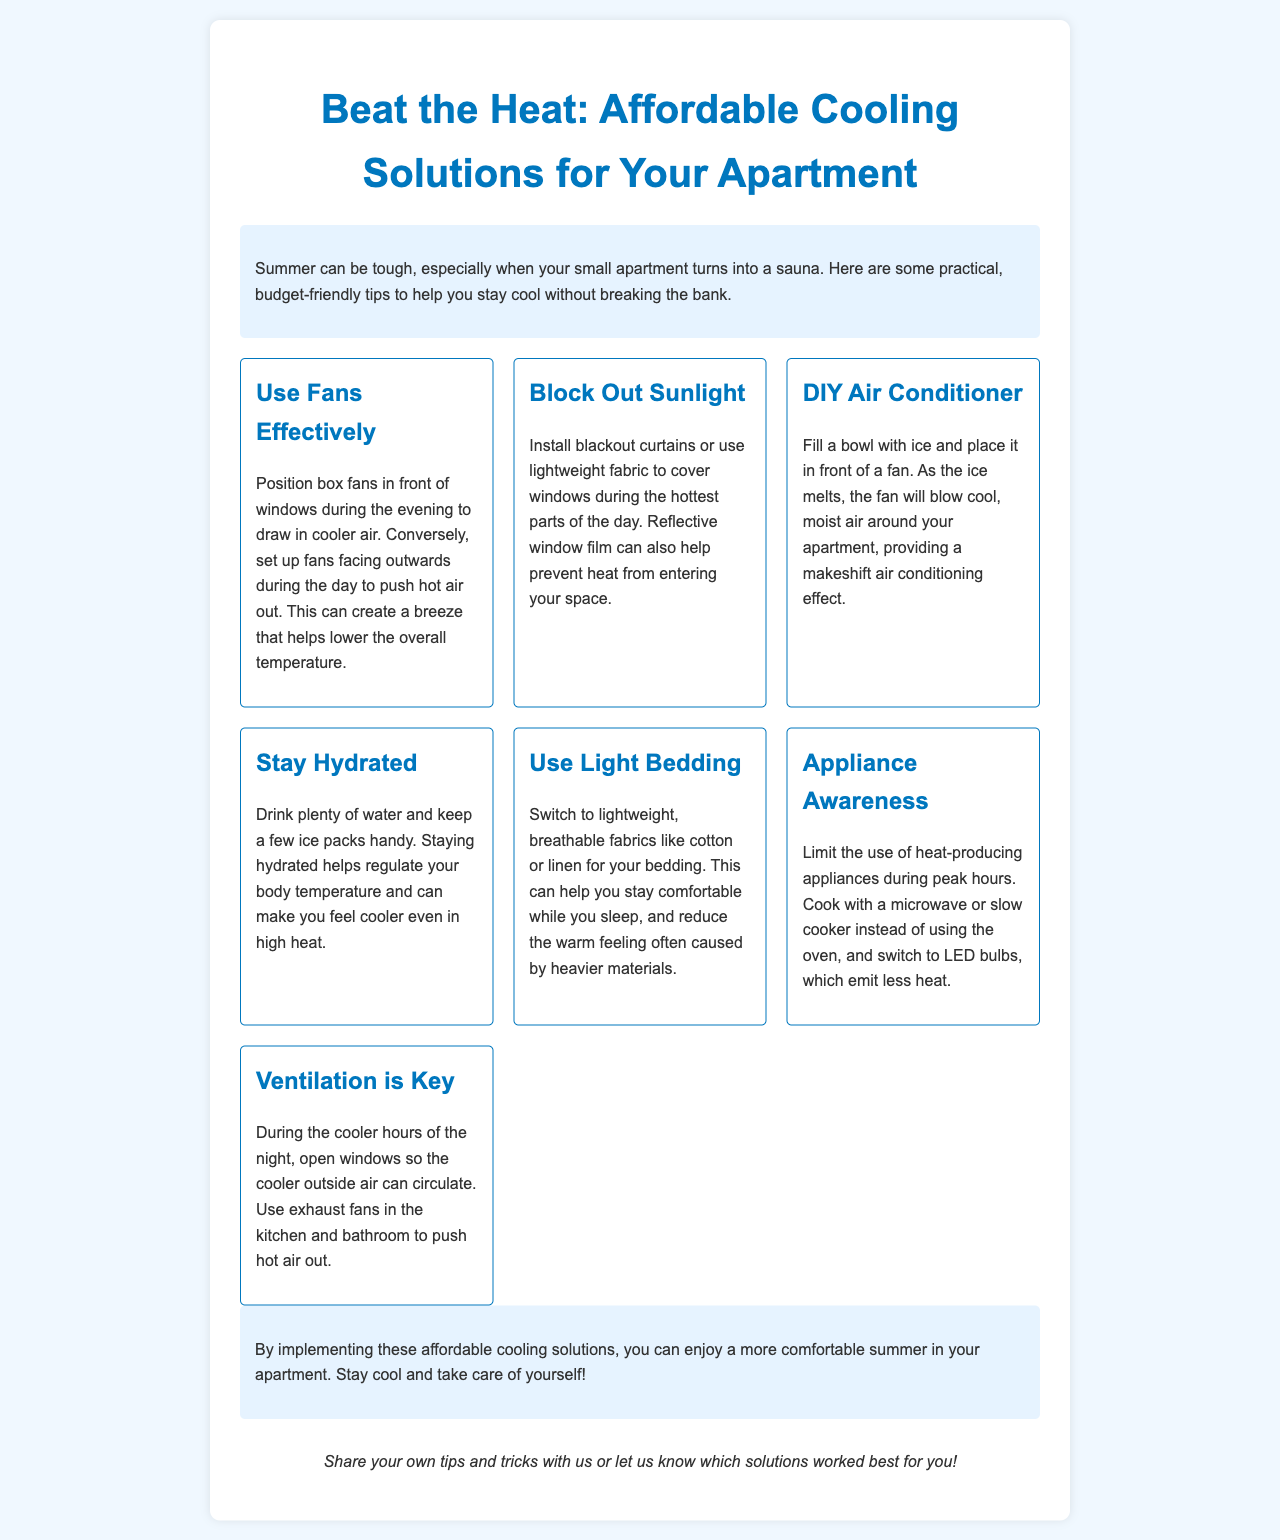What is the title of the newsletter? The title of the newsletter is presented at the top of the document, stating the main focus on cooling solutions for apartments.
Answer: Beat the Heat: Affordable Cooling Solutions for Your Apartment How many tips are provided in the newsletter? The newsletter lists several distinct tips in separate sections, totaling the number of cooling solutions suggested.
Answer: Seven What materials are suggested for lightweight bedding? The document specifies the types of fabrics recommended for staying comfortable during hot weather.
Answer: Cotton or linen What is a recommended solution to create a makeshift air conditioner? The newsletter outlines a simple DIY method to cool the apartment using common household items.
Answer: Fill a bowl with ice and place it in front of a fan What time of day is suggested for opening windows? The newsletter indicates which times are best for maximizing airflow and cooling through open windows.
Answer: During the cooler hours of the night What is emphasized as key to staying cool in hot weather? The document highlights an essential action that should be taken to lower heat levels in the apartment effectively.
Answer: Ventilation What should you limit using during peak hours? The newsletter advises on certain practices to avoid for keeping the apartment cooler during extreme temperatures.
Answer: Heat-producing appliances 